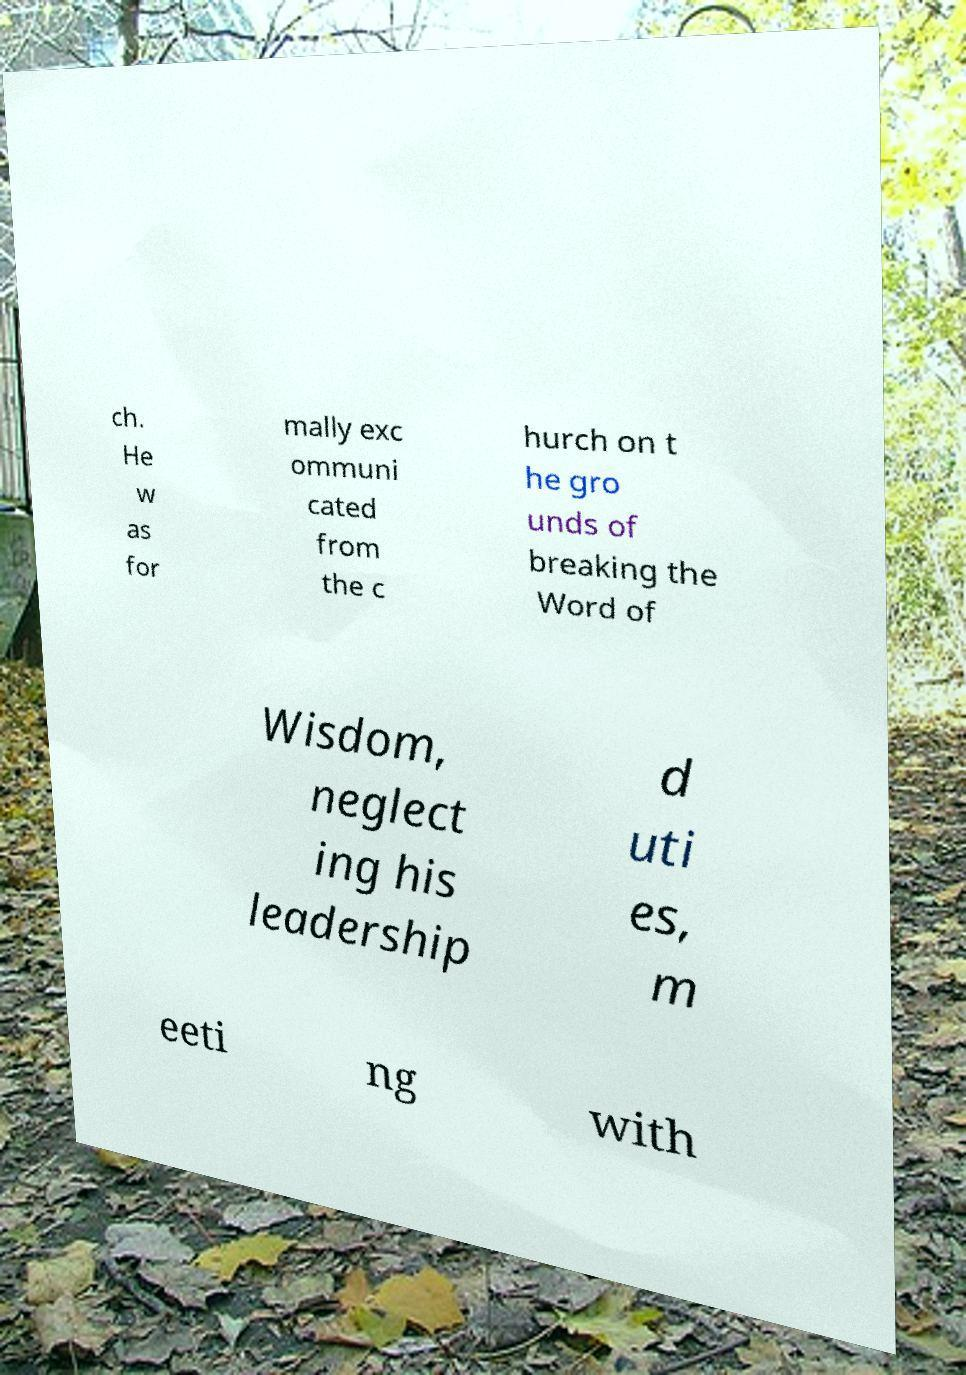Could you extract and type out the text from this image? ch. He w as for mally exc ommuni cated from the c hurch on t he gro unds of breaking the Word of Wisdom, neglect ing his leadership d uti es, m eeti ng with 